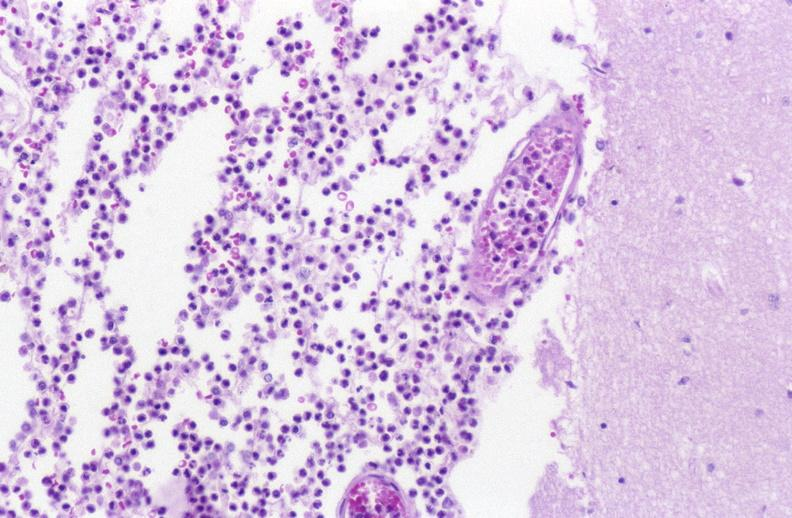where is this?
Answer the question using a single word or phrase. Nervous 